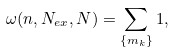Convert formula to latex. <formula><loc_0><loc_0><loc_500><loc_500>\omega ( n , N _ { e x } , N ) = \sum _ { \{ m _ { k } \} } 1 ,</formula> 